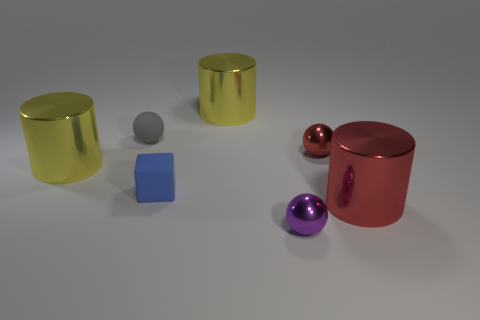Add 1 tiny yellow metal balls. How many objects exist? 8 Subtract all blocks. How many objects are left? 6 Subtract all small blue cylinders. Subtract all small blocks. How many objects are left? 6 Add 3 small matte balls. How many small matte balls are left? 4 Add 2 blue balls. How many blue balls exist? 2 Subtract 1 yellow cylinders. How many objects are left? 6 